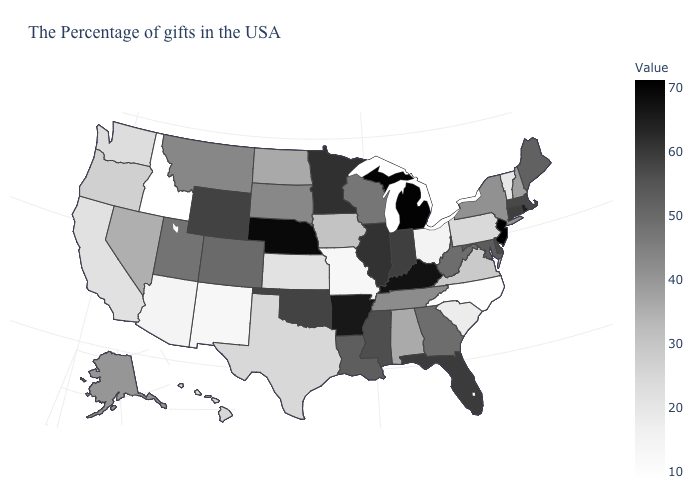Which states hav the highest value in the South?
Write a very short answer. Kentucky. Among the states that border Maine , which have the lowest value?
Short answer required. New Hampshire. 